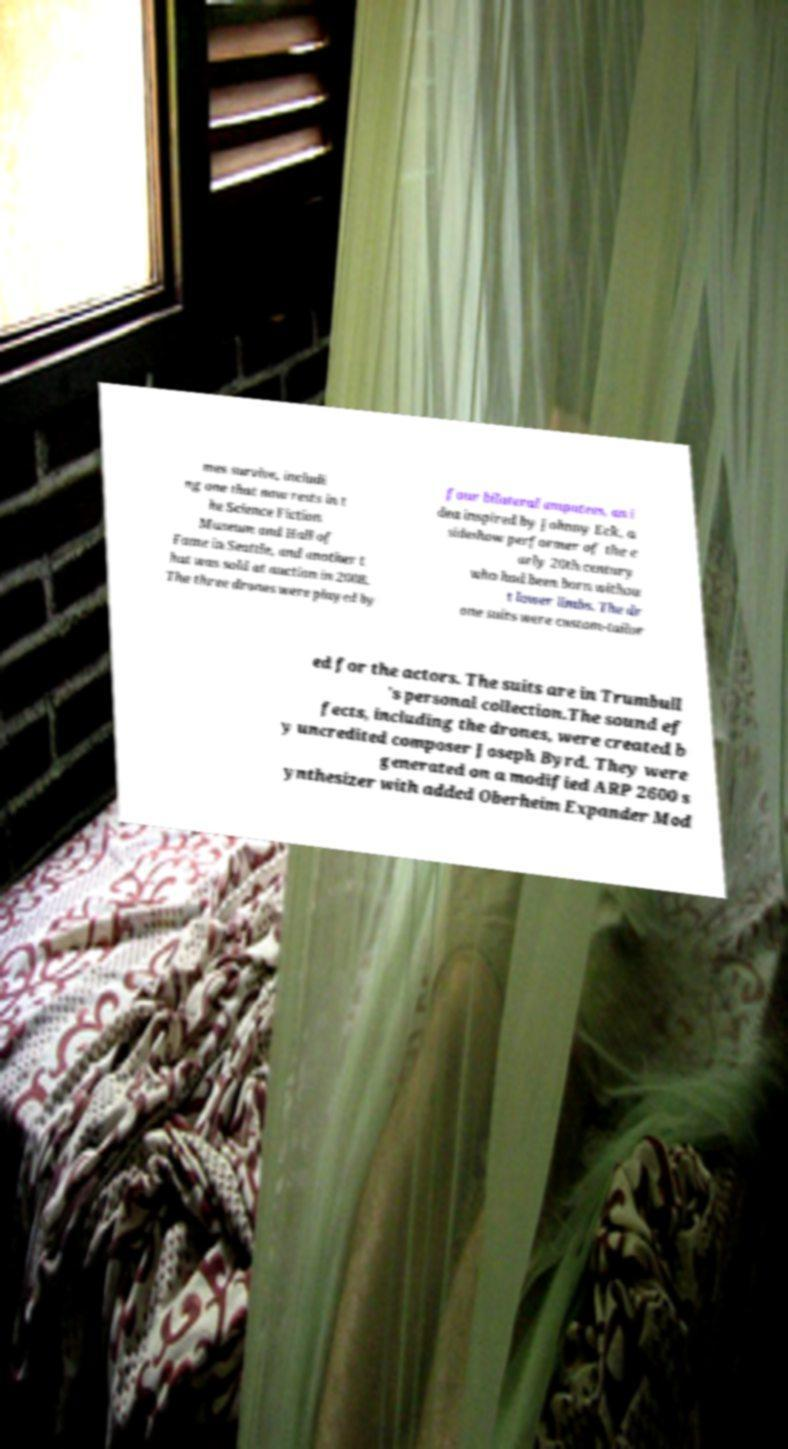Please read and relay the text visible in this image. What does it say? mes survive, includi ng one that now rests in t he Science Fiction Museum and Hall of Fame in Seattle, and another t hat was sold at auction in 2008. The three drones were played by four bilateral amputees, an i dea inspired by Johnny Eck, a sideshow performer of the e arly 20th century who had been born withou t lower limbs. The dr one suits were custom-tailor ed for the actors. The suits are in Trumbull 's personal collection.The sound ef fects, including the drones, were created b y uncredited composer Joseph Byrd. They were generated on a modified ARP 2600 s ynthesizer with added Oberheim Expander Mod 